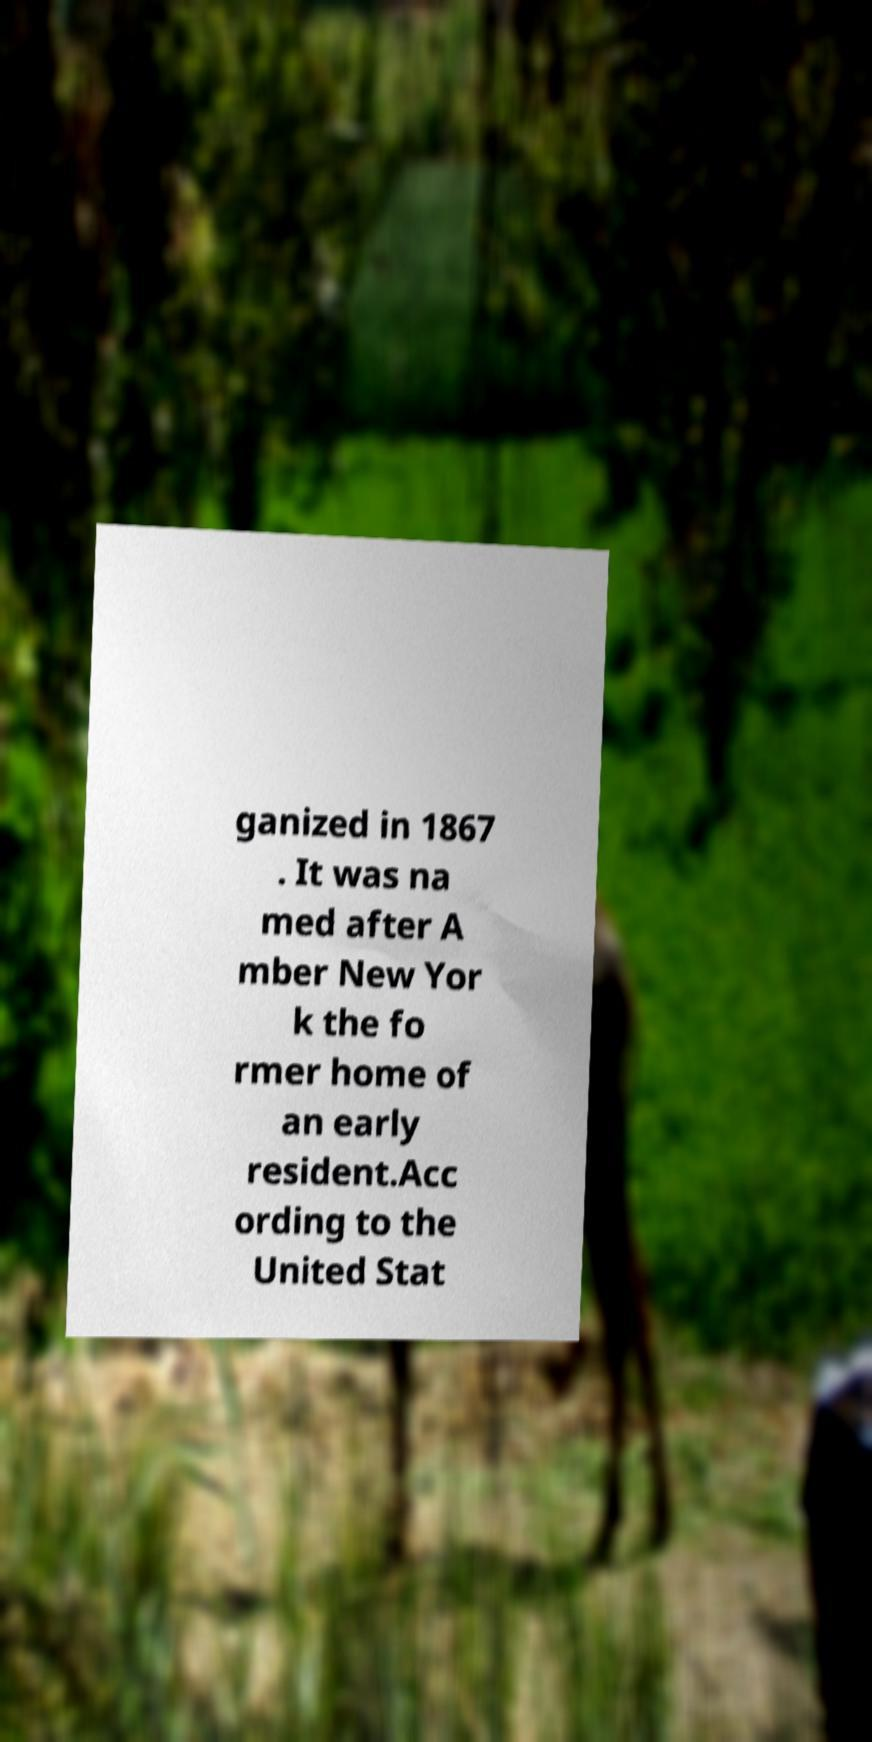Please identify and transcribe the text found in this image. ganized in 1867 . It was na med after A mber New Yor k the fo rmer home of an early resident.Acc ording to the United Stat 